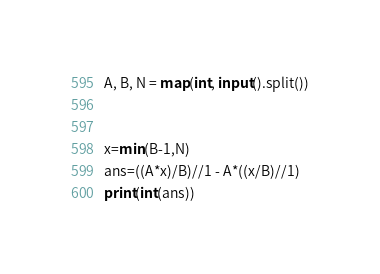<code> <loc_0><loc_0><loc_500><loc_500><_Python_>A, B, N = map(int, input().split())


x=min(B-1,N)
ans=((A*x)/B)//1 - A*((x/B)//1)
print(int(ans))

</code> 